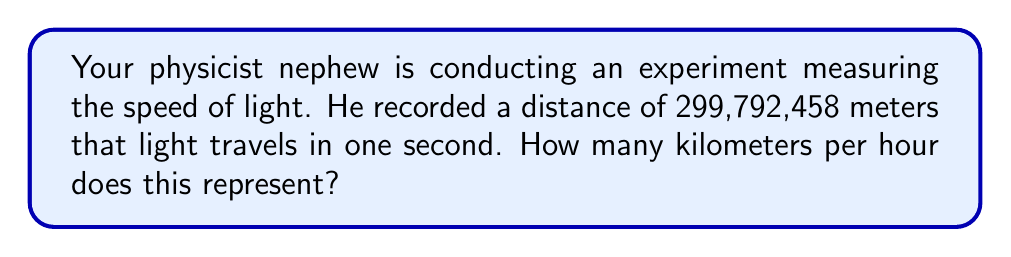Teach me how to tackle this problem. Let's approach this step-by-step:

1) First, we need to convert meters to kilometers:
   $299,792,458 \text{ meters} = 299,792.458 \text{ kilometers}$

2) We already know this is the distance light travels in one second. To convert this to kilometers per hour, we need to multiply by the number of seconds in an hour:

   $299,792.458 \text{ km/s} \times 3600 \text{ s/hr}$

3) Let's perform this multiplication:

   $$299,792.458 \times 3600 = 1,079,252,848.8 \text{ km/hr}$$

Therefore, the speed of light is approximately 1,079,252,848.8 kilometers per hour.
Answer: $1,079,252,848.8 \text{ km/hr}$ 